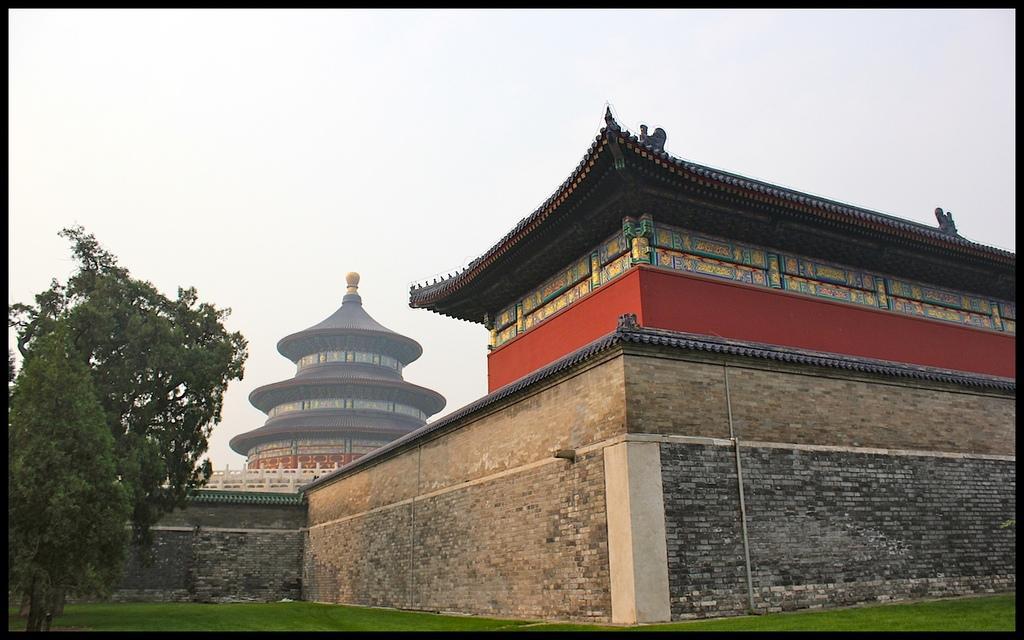Please provide a concise description of this image. In the center of the image we can see the sky, trees, one building and grass. And we can see the black colored border around the image. 